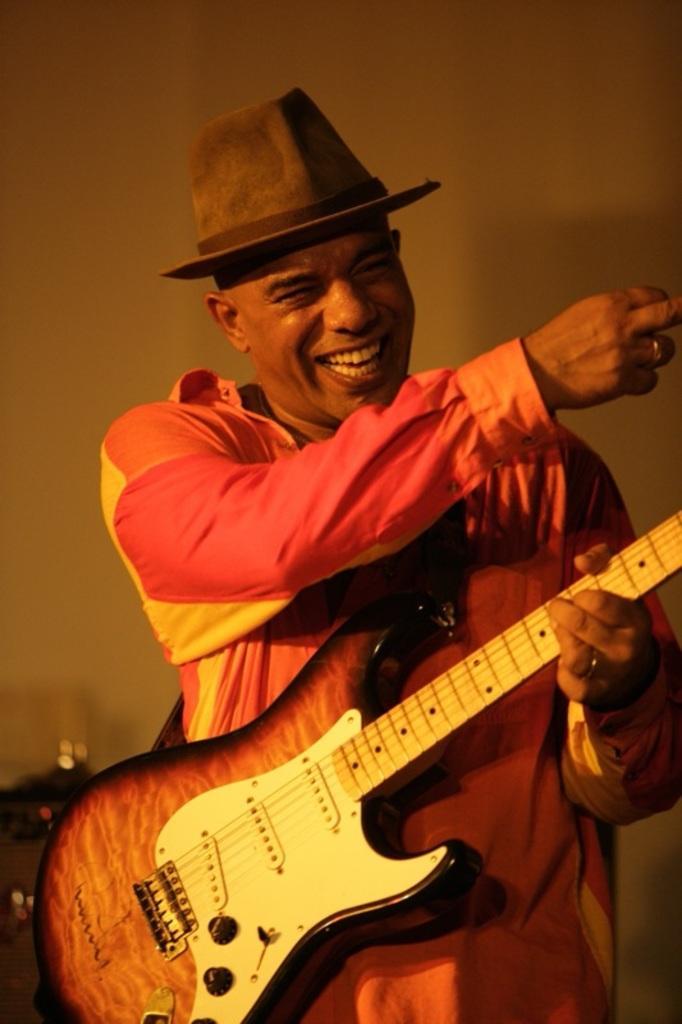In one or two sentences, can you explain what this image depicts? A man with pink shirt is standing and holding a guitar in his hand. He is laughing. On his head there is a hat. 